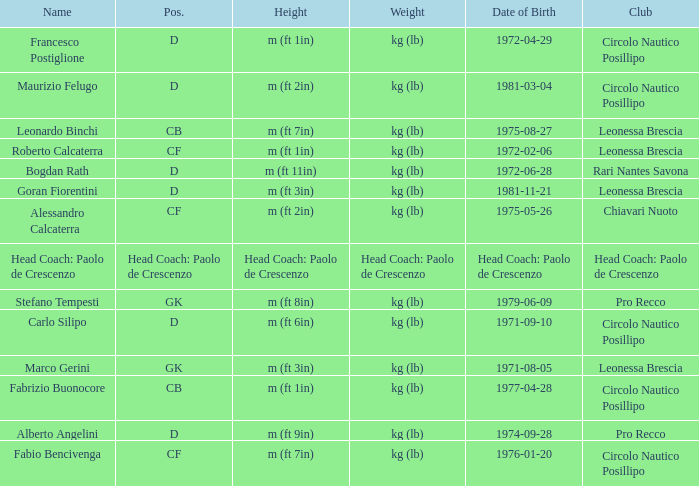What is the weight of the entry that has a date of birth of 1981-11-21? Kg (lb). 